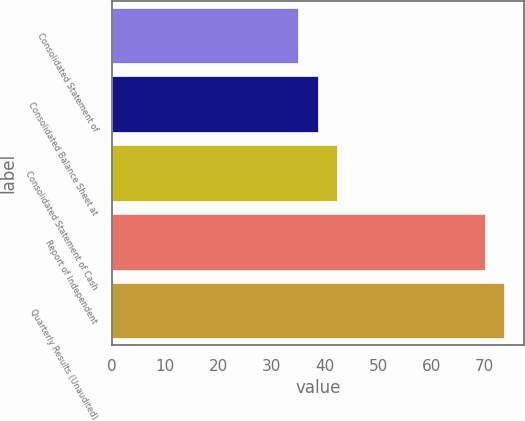Convert chart to OTSL. <chart><loc_0><loc_0><loc_500><loc_500><bar_chart><fcel>Consolidated Statement of<fcel>Consolidated Balance Sheet at<fcel>Consolidated Statement of Cash<fcel>Report of Independent<fcel>Quarterly Results (Unaudited)<nl><fcel>35<fcel>38.6<fcel>42.2<fcel>70<fcel>73.6<nl></chart> 